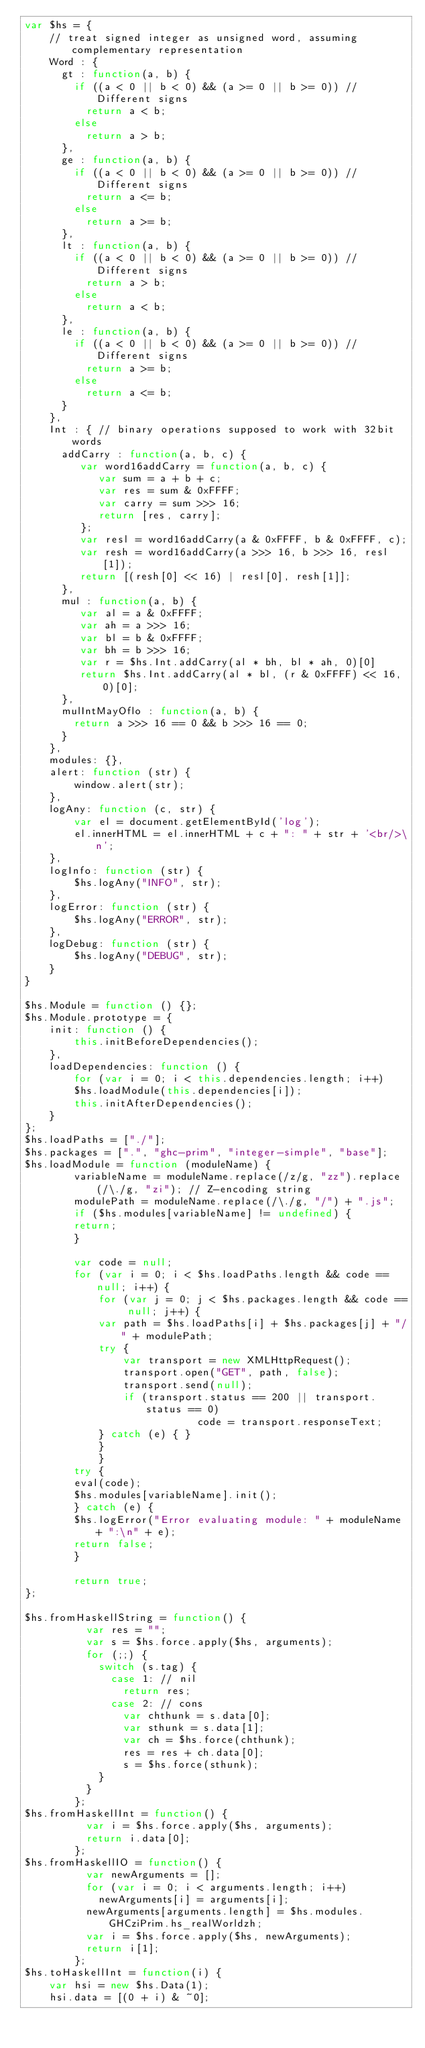Convert code to text. <code><loc_0><loc_0><loc_500><loc_500><_JavaScript_>var $hs = {
    // treat signed integer as unsigned word, assuming complementary representation
    Word : {
      gt : function(a, b) {
        if ((a < 0 || b < 0) && (a >= 0 || b >= 0)) // Different signs
          return a < b;
        else
          return a > b;
      },
      ge : function(a, b) {
        if ((a < 0 || b < 0) && (a >= 0 || b >= 0)) // Different signs
          return a <= b;
        else
          return a >= b;
      },
      lt : function(a, b) {
        if ((a < 0 || b < 0) && (a >= 0 || b >= 0)) // Different signs
          return a > b;
        else
          return a < b;
      },
      le : function(a, b) {
        if ((a < 0 || b < 0) && (a >= 0 || b >= 0)) // Different signs
          return a >= b;
        else
          return a <= b;
      }
    },
    Int : { // binary operations supposed to work with 32bit words
      addCarry : function(a, b, c) {
         var word16addCarry = function(a, b, c) {
            var sum = a + b + c;
            var res = sum & 0xFFFF;
            var carry = sum >>> 16;
            return [res, carry];
         };
         var resl = word16addCarry(a & 0xFFFF, b & 0xFFFF, c);
         var resh = word16addCarry(a >>> 16, b >>> 16, resl[1]);
         return [(resh[0] << 16) | resl[0], resh[1]];
      },
      mul : function(a, b) {
         var al = a & 0xFFFF;
         var ah = a >>> 16;
         var bl = b & 0xFFFF;
         var bh = b >>> 16;
         var r = $hs.Int.addCarry(al * bh, bl * ah, 0)[0]
         return $hs.Int.addCarry(al * bl, (r & 0xFFFF) << 16, 0)[0];
      },
      mulIntMayOflo : function(a, b) {
        return a >>> 16 == 0 && b >>> 16 == 0;
      }
    },
    modules: {},
    alert: function (str) {
        window.alert(str);
    },
    logAny: function (c, str) {
        var el = document.getElementById('log');
        el.innerHTML = el.innerHTML + c + ": " + str + '<br/>\n';
    },
    logInfo: function (str) {
        $hs.logAny("INFO", str);
    },
    logError: function (str) {
        $hs.logAny("ERROR", str);
    },
    logDebug: function (str) {
        $hs.logAny("DEBUG", str);
    }
}

$hs.Module = function () {};
$hs.Module.prototype = {
    init: function () {
        this.initBeforeDependencies();
    },
    loadDependencies: function () {
        for (var i = 0; i < this.dependencies.length; i++)
	    $hs.loadModule(this.dependencies[i]);
        this.initAfterDependencies();
    }
};
$hs.loadPaths = ["./"];
$hs.packages = [".", "ghc-prim", "integer-simple", "base"];
$hs.loadModule = function (moduleName) {
	    variableName = moduleName.replace(/z/g, "zz").replace(/\./g, "zi"); // Z-encoding string
	    modulePath = moduleName.replace(/\./g, "/") + ".js";
	    if ($hs.modules[variableName] != undefined) {
		return;
	    }

	    var code = null;
	    for (var i = 0; i < $hs.loadPaths.length && code == null; i++) {
	        for (var j = 0; j < $hs.packages.length && code == null; j++) {
		    var path = $hs.loadPaths[i] + $hs.packages[j] + "/" + modulePath;
		    try {
		        var transport = new XMLHttpRequest();
		        transport.open("GET", path, false);
		        transport.send(null);
		        if (transport.status == 200 || transport.status == 0)
                            code = transport.responseText;
		    } catch (e) { }
	        }
            }
	    try {
		eval(code);
		$hs.modules[variableName].init();
	    } catch (e) {
		$hs.logError("Error evaluating module: " + moduleName + ":\n" + e);
		return false;
	    }
	    
	    return true;
};

$hs.fromHaskellString = function() {
          var res = "";
          var s = $hs.force.apply($hs, arguments);
          for (;;) {
            switch (s.tag) {
              case 1: // nil
                return res;
              case 2: // cons
                var chthunk = s.data[0];
                var sthunk = s.data[1];
                var ch = $hs.force(chthunk);
                res = res + ch.data[0];
                s = $hs.force(sthunk);
            }
          }
        };
$hs.fromHaskellInt = function() {
          var i = $hs.force.apply($hs, arguments);
          return i.data[0];
        };
$hs.fromHaskellIO = function() {
          var newArguments = [];
          for (var i = 0; i < arguments.length; i++)
            newArguments[i] = arguments[i];
          newArguments[arguments.length] = $hs.modules.GHCziPrim.hs_realWorldzh;
          var i = $hs.force.apply($hs, newArguments);
          return i[1];
        };
$hs.toHaskellInt = function(i) {
    var hsi = new $hs.Data(1);
    hsi.data = [(0 + i) & ~0];</code> 